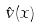<formula> <loc_0><loc_0><loc_500><loc_500>\hat { v } ( x )</formula> 